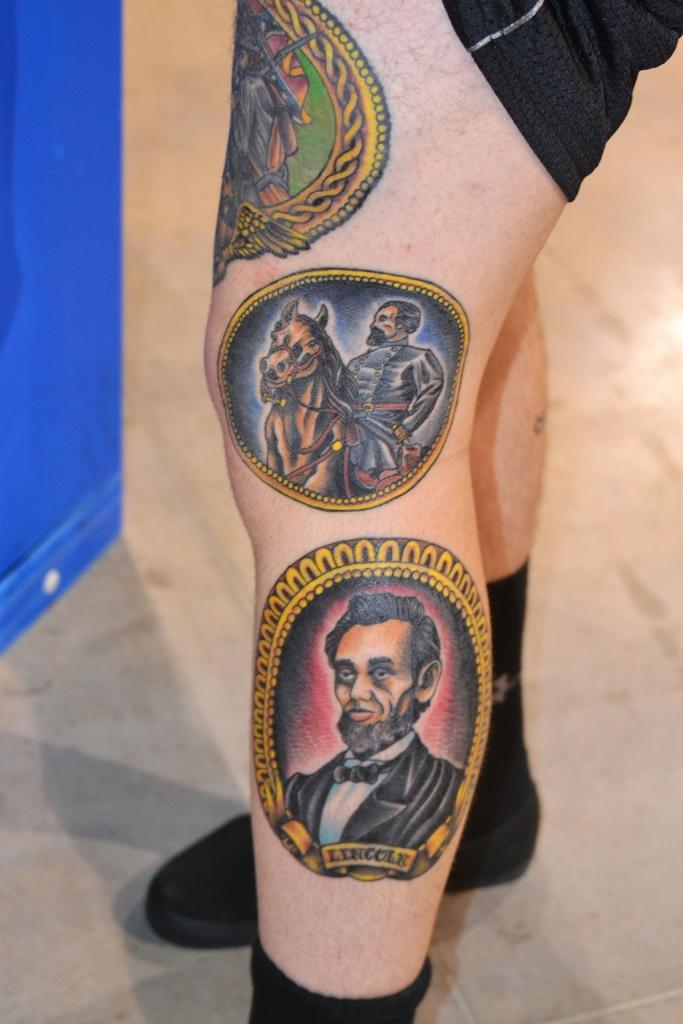What part of a person can be seen in the image? There are legs of a person in the image. What can be observed on the person's legs? The person has tattoos on their leg. What color object is on the left side of the image? There is a blue color object on the left side of the image. What type of milk is being served during the recess in the image? There is no recess or milk present in the image; it only features a person's legs with tattoos and a blue color object on the left side. 